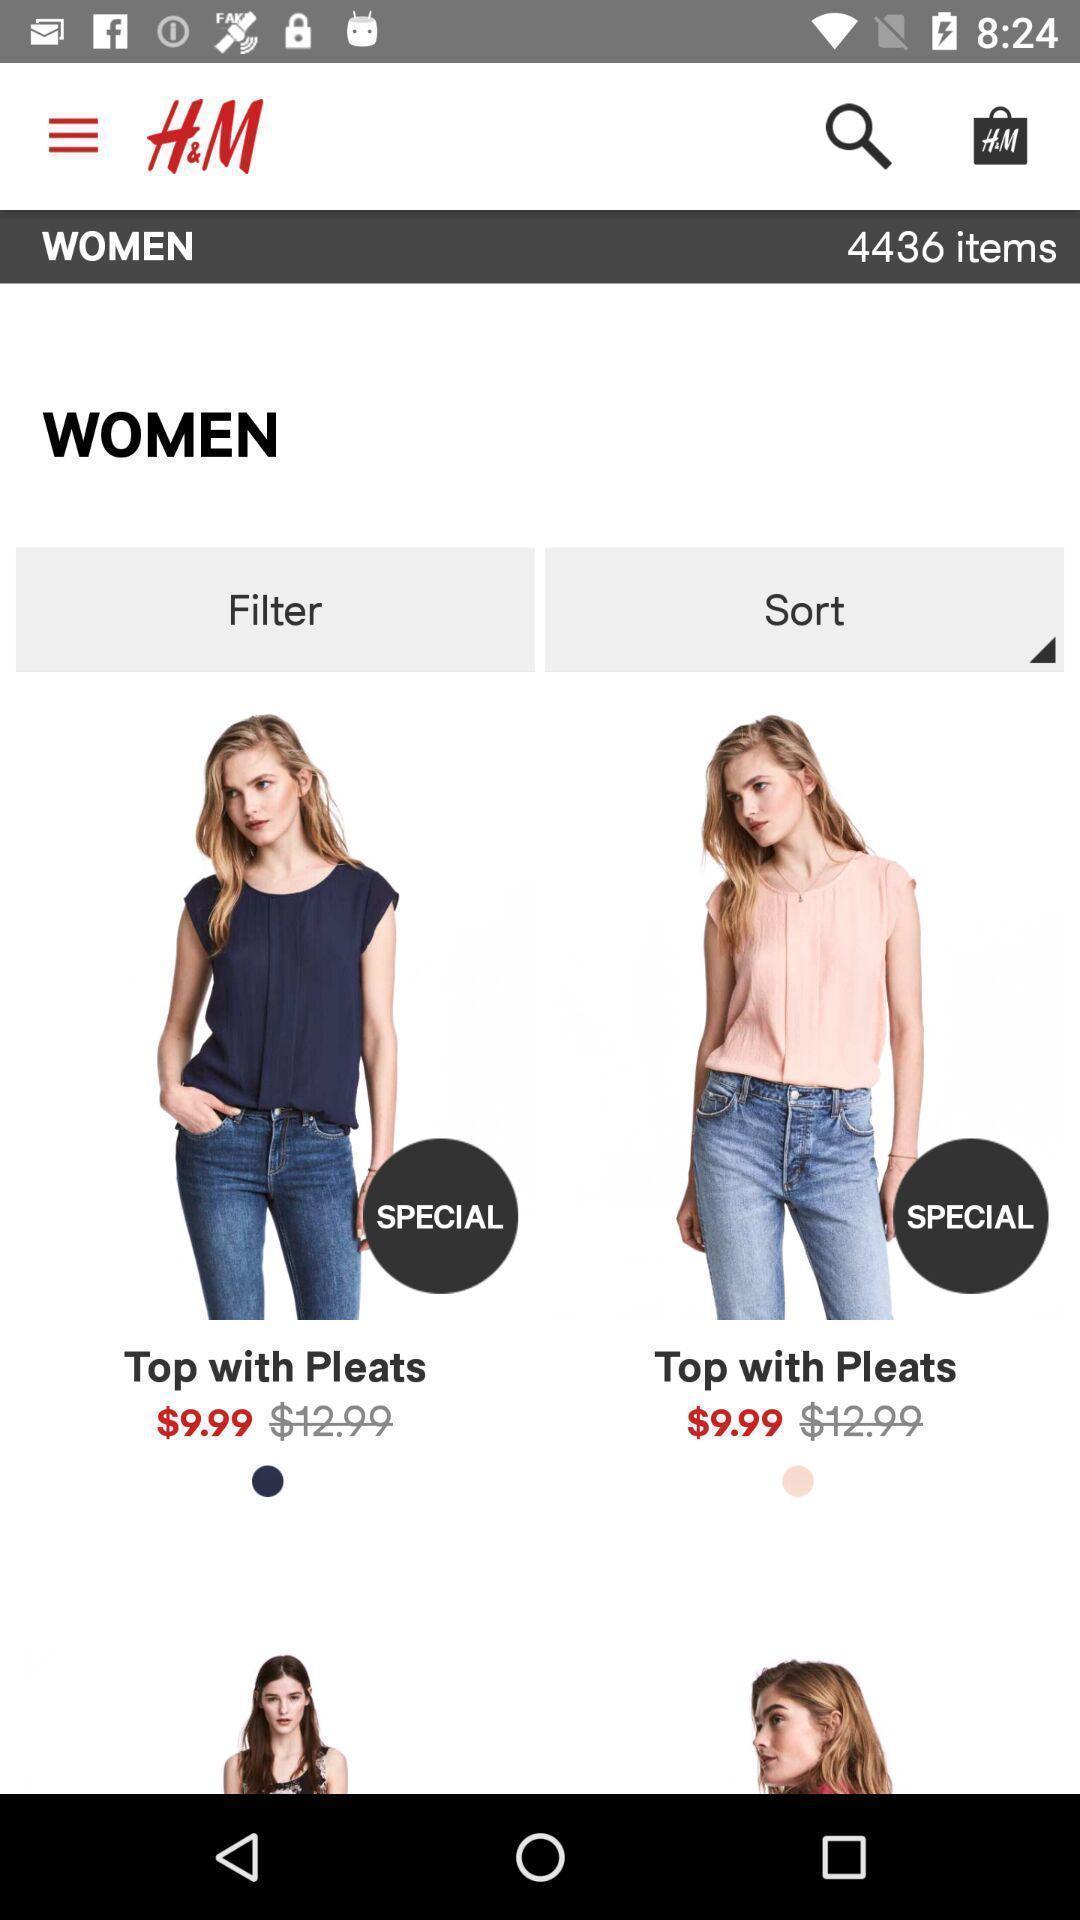Give me a narrative description of this picture. Welcome page of an online shopping app. 